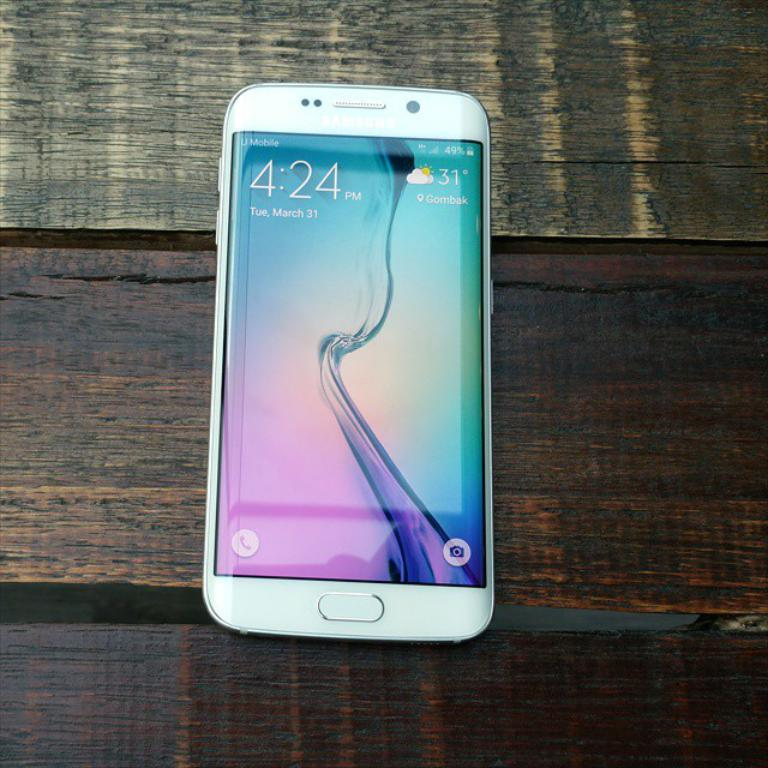<image>
Share a concise interpretation of the image provided. Samsung Phone with home screen open at the time 4:24 on March 31. 